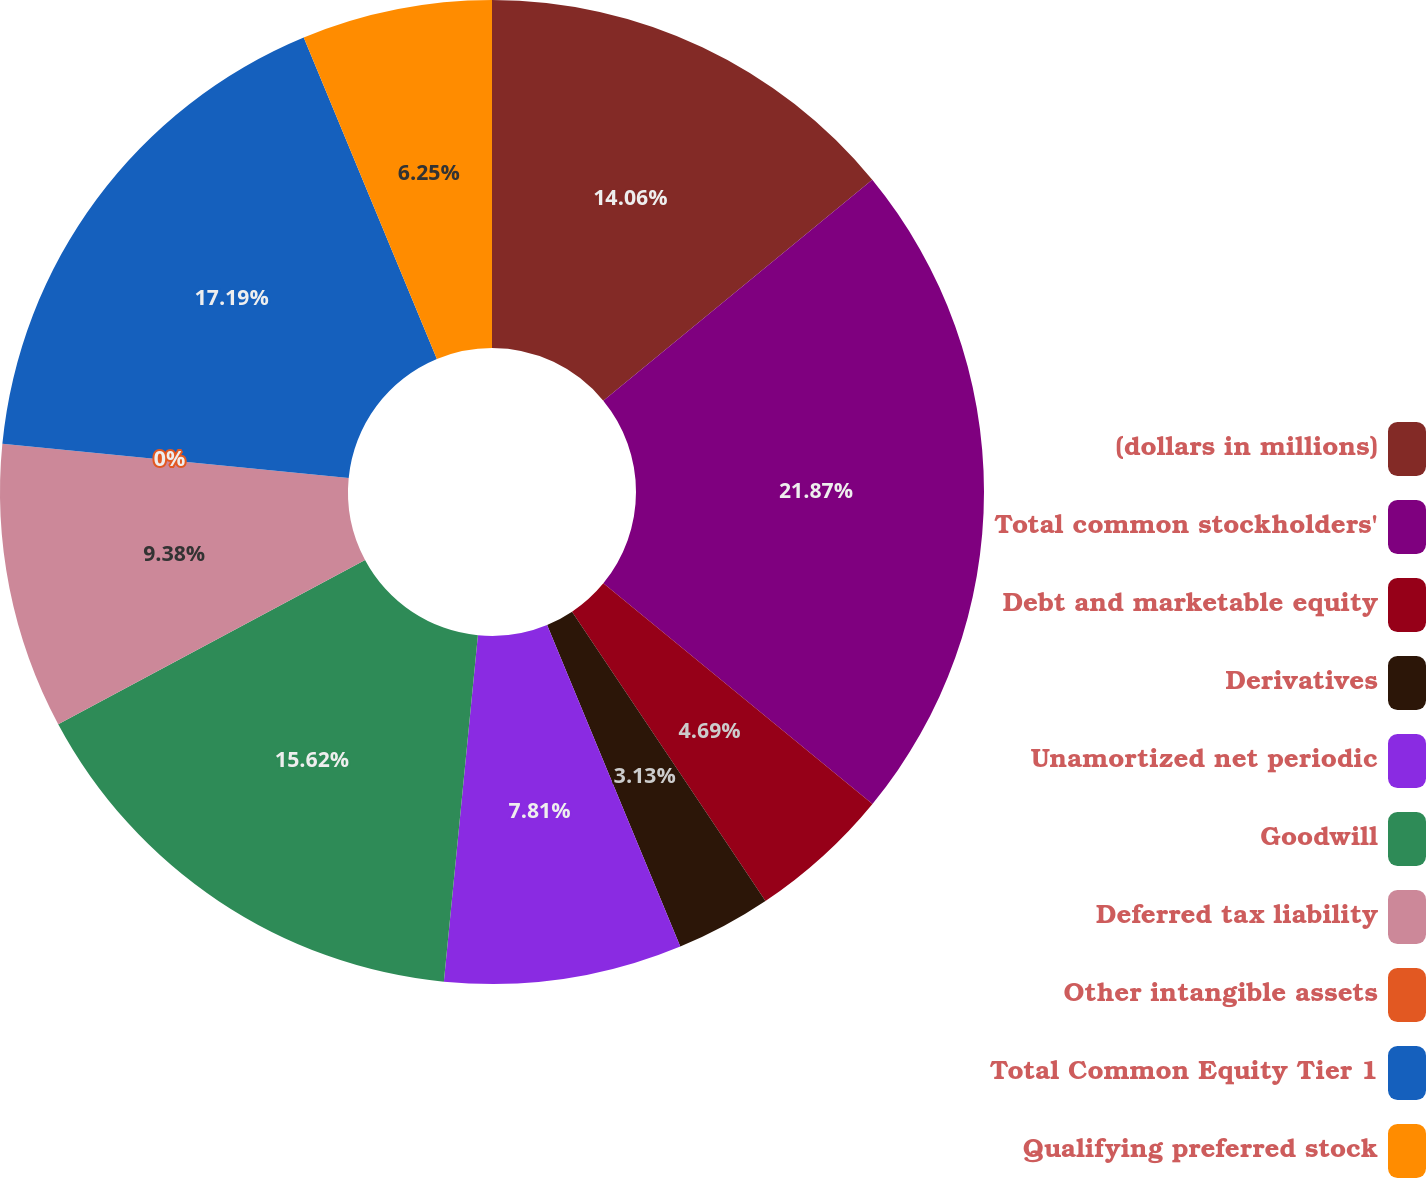Convert chart. <chart><loc_0><loc_0><loc_500><loc_500><pie_chart><fcel>(dollars in millions)<fcel>Total common stockholders'<fcel>Debt and marketable equity<fcel>Derivatives<fcel>Unamortized net periodic<fcel>Goodwill<fcel>Deferred tax liability<fcel>Other intangible assets<fcel>Total Common Equity Tier 1<fcel>Qualifying preferred stock<nl><fcel>14.06%<fcel>21.87%<fcel>4.69%<fcel>3.13%<fcel>7.81%<fcel>15.62%<fcel>9.38%<fcel>0.0%<fcel>17.19%<fcel>6.25%<nl></chart> 